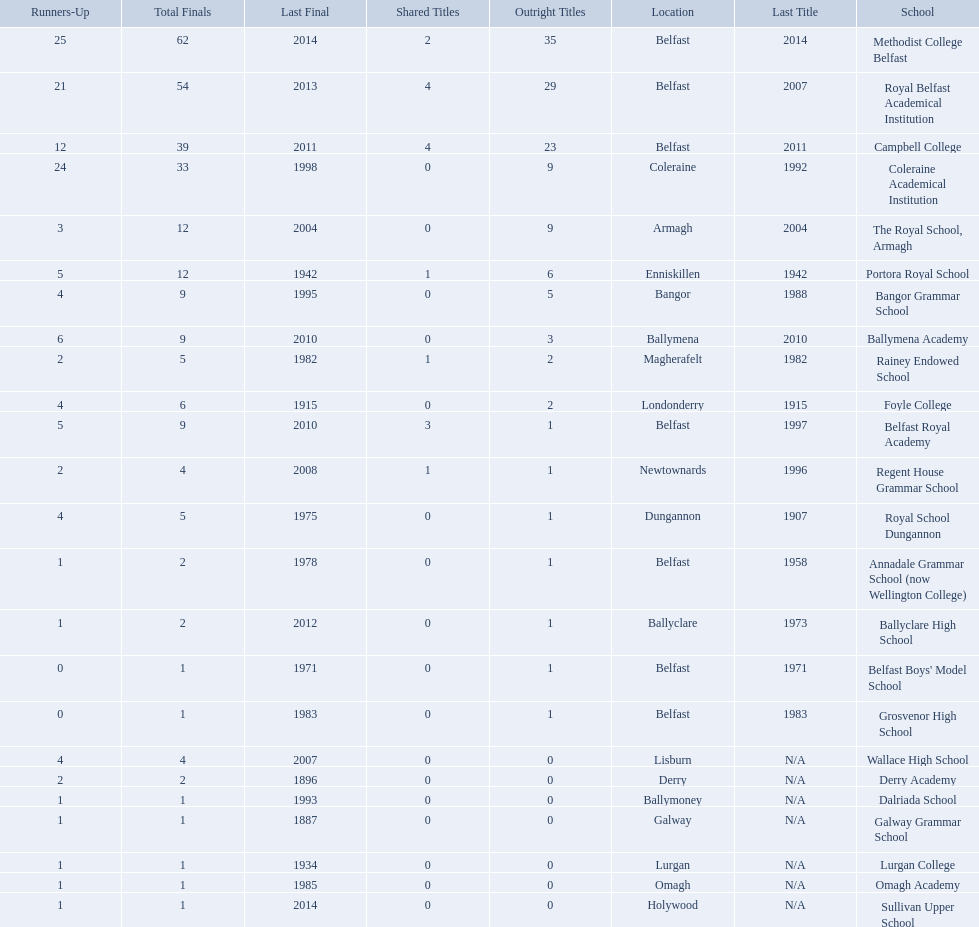Which schools are listed? Methodist College Belfast, Royal Belfast Academical Institution, Campbell College, Coleraine Academical Institution, The Royal School, Armagh, Portora Royal School, Bangor Grammar School, Ballymena Academy, Rainey Endowed School, Foyle College, Belfast Royal Academy, Regent House Grammar School, Royal School Dungannon, Annadale Grammar School (now Wellington College), Ballyclare High School, Belfast Boys' Model School, Grosvenor High School, Wallace High School, Derry Academy, Dalriada School, Galway Grammar School, Lurgan College, Omagh Academy, Sullivan Upper School. When did campbell college win the title last? 2011. When did regent house grammar school win the title last? 1996. Of those two who had the most recent title win? Campbell College. 